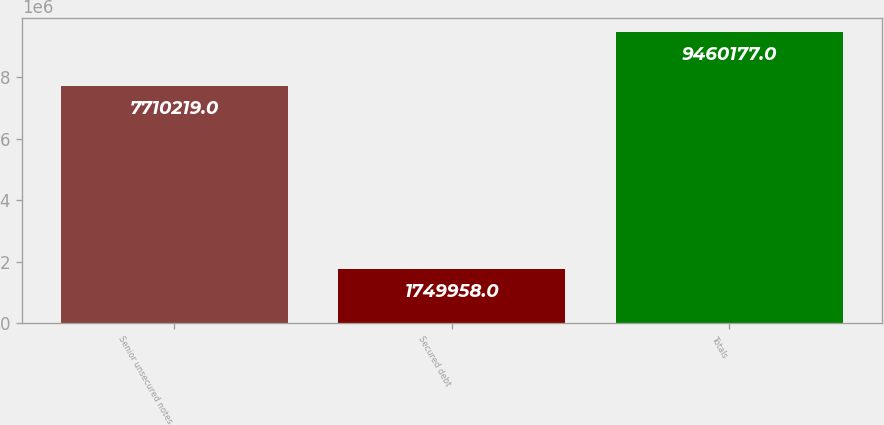<chart> <loc_0><loc_0><loc_500><loc_500><bar_chart><fcel>Senior unsecured notes<fcel>Secured debt<fcel>Totals<nl><fcel>7.71022e+06<fcel>1.74996e+06<fcel>9.46018e+06<nl></chart> 